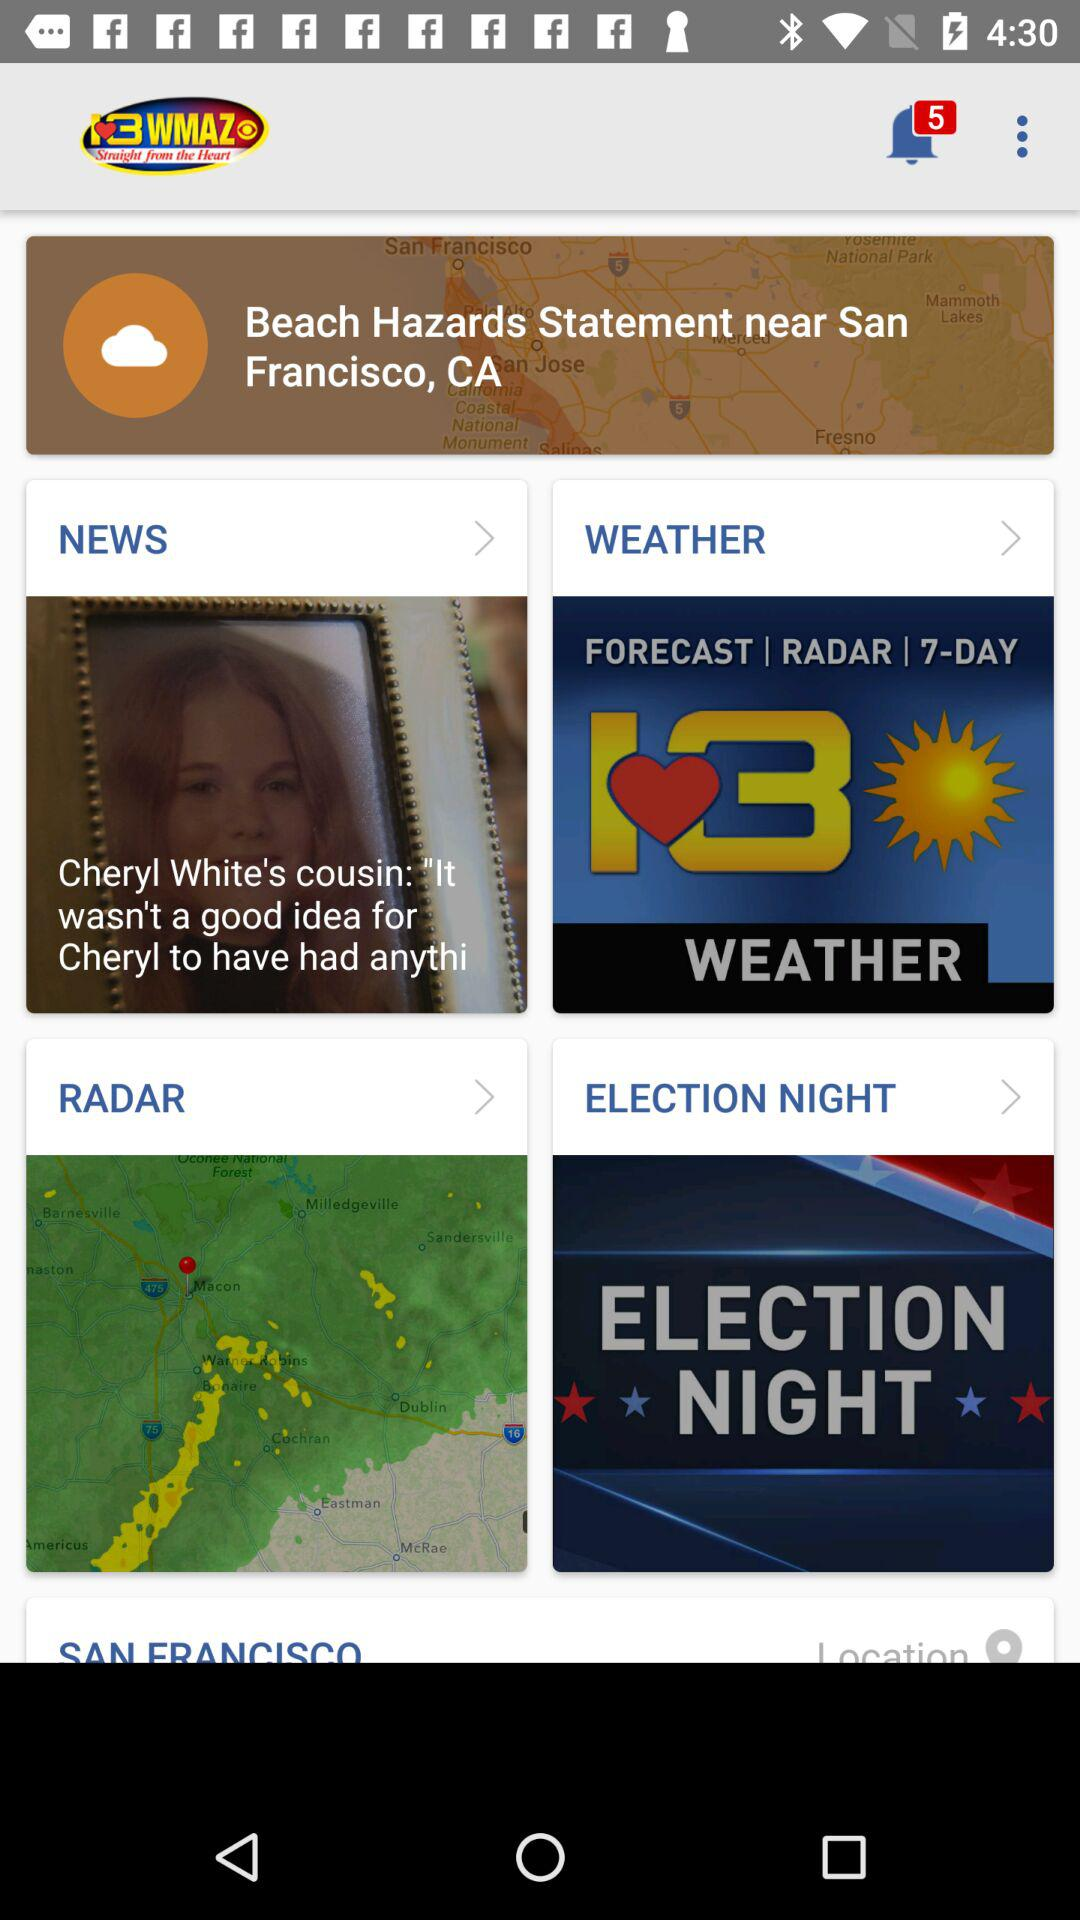Where are beach hazards likely to appear? Beach hazards are likely to appear near San Francisco, CA. 